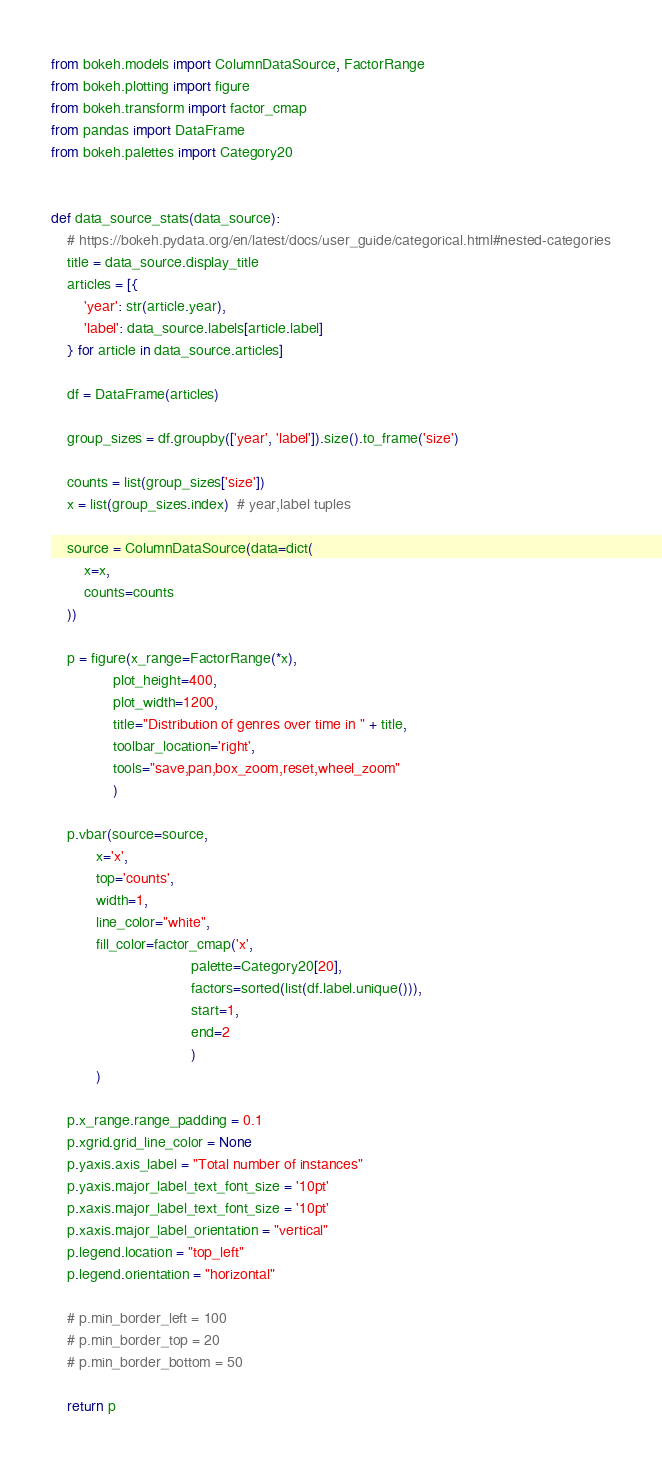<code> <loc_0><loc_0><loc_500><loc_500><_Python_>from bokeh.models import ColumnDataSource, FactorRange
from bokeh.plotting import figure
from bokeh.transform import factor_cmap
from pandas import DataFrame
from bokeh.palettes import Category20


def data_source_stats(data_source):
    # https://bokeh.pydata.org/en/latest/docs/user_guide/categorical.html#nested-categories
    title = data_source.display_title
    articles = [{
        'year': str(article.year),
        'label': data_source.labels[article.label]
    } for article in data_source.articles]

    df = DataFrame(articles)

    group_sizes = df.groupby(['year', 'label']).size().to_frame('size')

    counts = list(group_sizes['size'])
    x = list(group_sizes.index)  # year,label tuples

    source = ColumnDataSource(data=dict(
        x=x,
        counts=counts
    ))

    p = figure(x_range=FactorRange(*x),
               plot_height=400,
               plot_width=1200,
               title="Distribution of genres over time in " + title,
               toolbar_location='right',
               tools="save,pan,box_zoom,reset,wheel_zoom"
               )

    p.vbar(source=source,
           x='x',
           top='counts',
           width=1,
           line_color="white",
           fill_color=factor_cmap('x',
                                  palette=Category20[20],
                                  factors=sorted(list(df.label.unique())),
                                  start=1,
                                  end=2
                                  )
           )

    p.x_range.range_padding = 0.1
    p.xgrid.grid_line_color = None
    p.yaxis.axis_label = "Total number of instances"
    p.yaxis.major_label_text_font_size = '10pt'
    p.xaxis.major_label_text_font_size = '10pt'
    p.xaxis.major_label_orientation = "vertical"
    p.legend.location = "top_left"
    p.legend.orientation = "horizontal"

    # p.min_border_left = 100
    # p.min_border_top = 20
    # p.min_border_bottom = 50

    return p</code> 